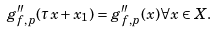<formula> <loc_0><loc_0><loc_500><loc_500>g _ { f , p } ^ { \prime \prime } ( \tau x + x _ { 1 } ) = g _ { f , p } ^ { \prime \prime } ( x ) \forall x \in X .</formula> 